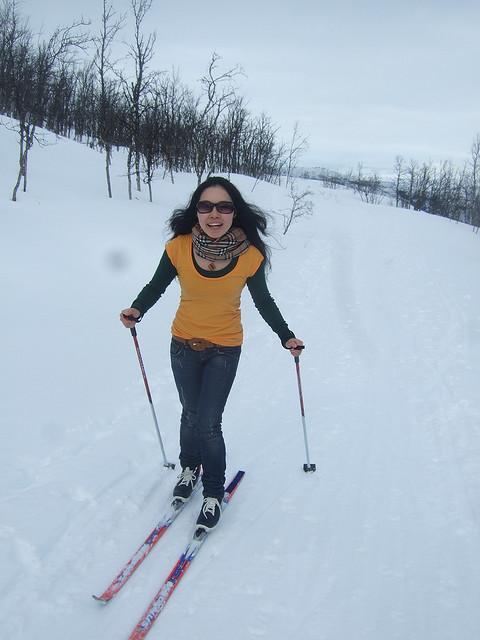What is the woman doing?
Short answer required. Skiing. What color is the woman's suit?
Give a very brief answer. Yellow. Is the skier wearing a coat?
Give a very brief answer. No. Where was the picture taken of the woman?
Write a very short answer. Outside. 